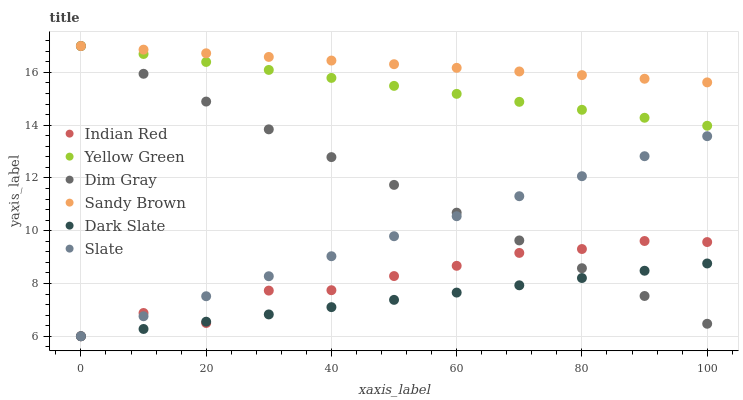Does Dark Slate have the minimum area under the curve?
Answer yes or no. Yes. Does Sandy Brown have the maximum area under the curve?
Answer yes or no. Yes. Does Yellow Green have the minimum area under the curve?
Answer yes or no. No. Does Yellow Green have the maximum area under the curve?
Answer yes or no. No. Is Slate the smoothest?
Answer yes or no. Yes. Is Indian Red the roughest?
Answer yes or no. Yes. Is Yellow Green the smoothest?
Answer yes or no. No. Is Yellow Green the roughest?
Answer yes or no. No. Does Slate have the lowest value?
Answer yes or no. Yes. Does Yellow Green have the lowest value?
Answer yes or no. No. Does Sandy Brown have the highest value?
Answer yes or no. Yes. Does Slate have the highest value?
Answer yes or no. No. Is Slate less than Yellow Green?
Answer yes or no. Yes. Is Yellow Green greater than Indian Red?
Answer yes or no. Yes. Does Indian Red intersect Slate?
Answer yes or no. Yes. Is Indian Red less than Slate?
Answer yes or no. No. Is Indian Red greater than Slate?
Answer yes or no. No. Does Slate intersect Yellow Green?
Answer yes or no. No. 